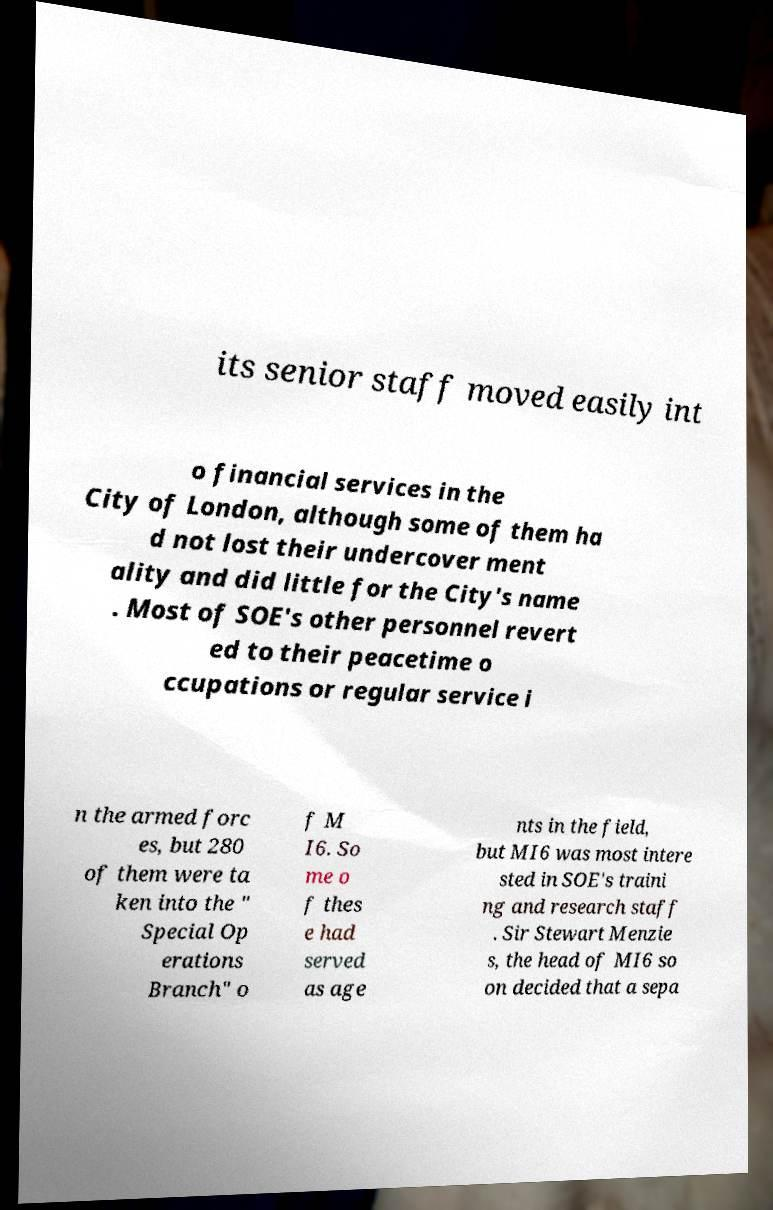Please read and relay the text visible in this image. What does it say? its senior staff moved easily int o financial services in the City of London, although some of them ha d not lost their undercover ment ality and did little for the City's name . Most of SOE's other personnel revert ed to their peacetime o ccupations or regular service i n the armed forc es, but 280 of them were ta ken into the " Special Op erations Branch" o f M I6. So me o f thes e had served as age nts in the field, but MI6 was most intere sted in SOE's traini ng and research staff . Sir Stewart Menzie s, the head of MI6 so on decided that a sepa 